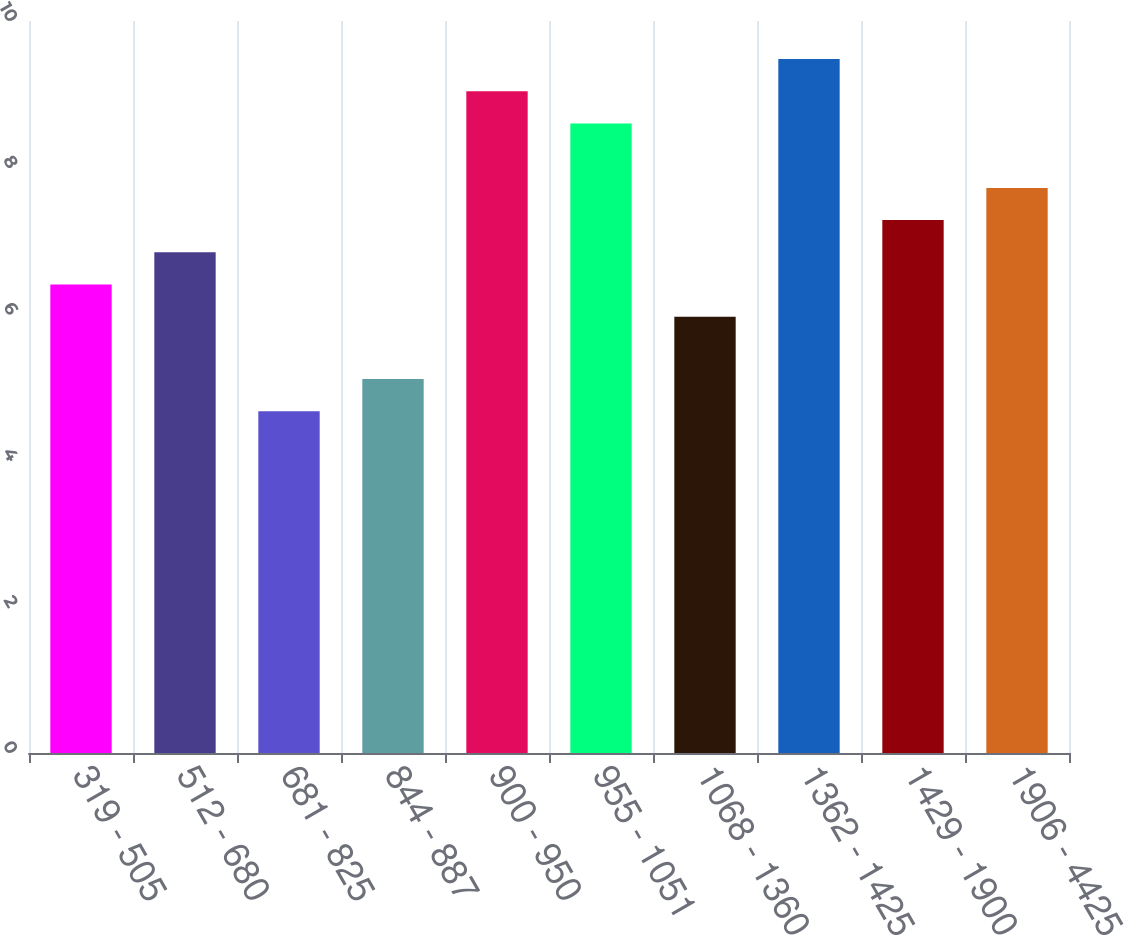<chart> <loc_0><loc_0><loc_500><loc_500><bar_chart><fcel>319 - 505<fcel>512 - 680<fcel>681 - 825<fcel>844 - 887<fcel>900 - 950<fcel>955 - 1051<fcel>1068 - 1360<fcel>1362 - 1425<fcel>1429 - 1900<fcel>1906 - 4425<nl><fcel>6.4<fcel>6.84<fcel>4.67<fcel>5.11<fcel>9.04<fcel>8.6<fcel>5.96<fcel>9.48<fcel>7.28<fcel>7.72<nl></chart> 